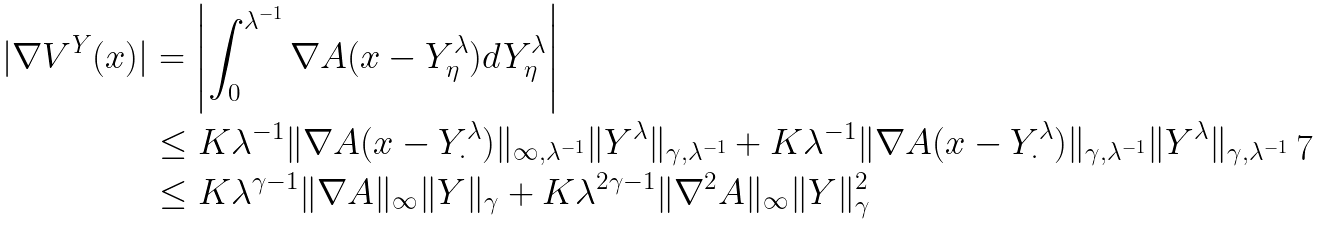Convert formula to latex. <formula><loc_0><loc_0><loc_500><loc_500>| \nabla V ^ { Y } ( x ) | & = \left | \int _ { 0 } ^ { \lambda ^ { - 1 } } \nabla A ( x - Y ^ { \lambda } _ { \eta } ) d Y ^ { \lambda } _ { \eta } \right | \\ & \leq K \lambda ^ { - 1 } \| \nabla A ( x - Y ^ { \lambda } _ { \cdot } ) \| _ { \infty , \lambda ^ { - 1 } } \| Y ^ { \lambda } \| _ { \gamma , \lambda ^ { - 1 } } + K \lambda ^ { - 1 } \| \nabla A ( x - Y ^ { \lambda } _ { \cdot } ) \| _ { \gamma , \lambda ^ { - 1 } } \| Y ^ { \lambda } \| _ { \gamma , \lambda ^ { - 1 } } \\ & \leq K \lambda ^ { \gamma - 1 } \| \nabla A \| _ { \infty } \| Y \| _ { \gamma } + K \lambda ^ { 2 \gamma - 1 } \| \nabla ^ { 2 } A \| _ { \infty } \| Y \| _ { \gamma } ^ { 2 }</formula> 